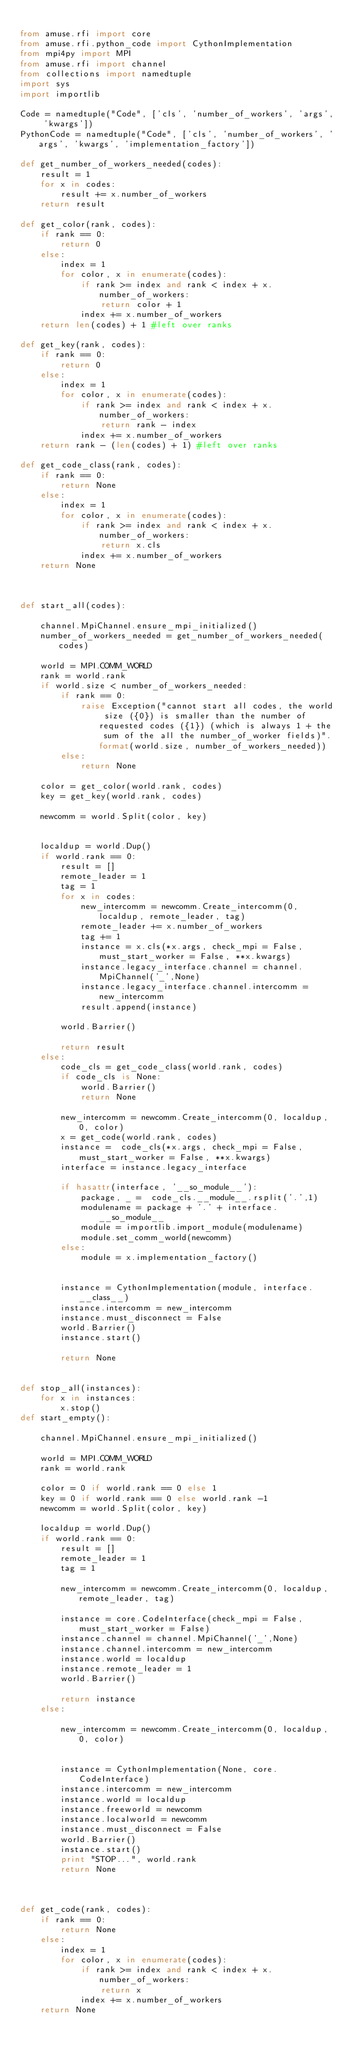Convert code to text. <code><loc_0><loc_0><loc_500><loc_500><_Python_>
from amuse.rfi import core
from amuse.rfi.python_code import CythonImplementation
from mpi4py import MPI
from amuse.rfi import channel
from collections import namedtuple
import sys
import importlib

Code = namedtuple("Code", ['cls', 'number_of_workers', 'args', 'kwargs'])
PythonCode = namedtuple("Code", ['cls', 'number_of_workers', 'args', 'kwargs', 'implementation_factory'])

def get_number_of_workers_needed(codes):
    result = 1
    for x in codes:
        result += x.number_of_workers
    return result

def get_color(rank, codes):
    if rank == 0:
        return 0
    else:
        index = 1
        for color, x in enumerate(codes):
            if rank >= index and rank < index + x.number_of_workers:
                return color + 1
            index += x.number_of_workers
    return len(codes) + 1 #left over ranks
            
def get_key(rank, codes):
    if rank == 0:
        return 0
    else:
        index = 1
        for color, x in enumerate(codes):
            if rank >= index and rank < index + x.number_of_workers:
                return rank - index
            index += x.number_of_workers
    return rank - (len(codes) + 1) #left over ranks

def get_code_class(rank, codes):
    if rank == 0:
        return None
    else:
        index = 1
        for color, x in enumerate(codes):
            if rank >= index and rank < index + x.number_of_workers:
                return x.cls
            index += x.number_of_workers
    return None
            
            

def start_all(codes):
    
    channel.MpiChannel.ensure_mpi_initialized()
    number_of_workers_needed = get_number_of_workers_needed(codes)
    
    world = MPI.COMM_WORLD
    rank = world.rank
    if world.size < number_of_workers_needed:
        if rank == 0:
            raise Exception("cannot start all codes, the world size ({0}) is smaller than the number of requested codes ({1}) (which is always 1 + the sum of the all the number_of_worker fields)".format(world.size, number_of_workers_needed))
        else:
            return None
    
    color = get_color(world.rank, codes)
    key = get_key(world.rank, codes)
    
    newcomm = world.Split(color, key)
    
    
    localdup = world.Dup()
    if world.rank == 0:
        result = []
        remote_leader = 1
        tag = 1
        for x in codes:
            new_intercomm = newcomm.Create_intercomm(0, localdup, remote_leader, tag)
            remote_leader += x.number_of_workers
            tag += 1
            instance = x.cls(*x.args, check_mpi = False, must_start_worker = False, **x.kwargs)
            instance.legacy_interface.channel = channel.MpiChannel('_',None)
            instance.legacy_interface.channel.intercomm = new_intercomm
            result.append(instance)
            
        world.Barrier()
        
        return result    
    else:
        code_cls = get_code_class(world.rank, codes)
        if code_cls is None:
            world.Barrier()
            return None
        
        new_intercomm = newcomm.Create_intercomm(0, localdup, 0, color)
        x = get_code(world.rank, codes)
        instance =  code_cls(*x.args, check_mpi = False, must_start_worker = False, **x.kwargs)
        interface = instance.legacy_interface
       
        if hasattr(interface, '__so_module__'):
            package, _ =  code_cls.__module__.rsplit('.',1)
            modulename = package + '.' + interface.__so_module__
            module = importlib.import_module(modulename)
            module.set_comm_world(newcomm)
        else:
            module = x.implementation_factory()
        
        
        instance = CythonImplementation(module, interface.__class__)
        instance.intercomm = new_intercomm
        instance.must_disconnect = False
        world.Barrier()
        instance.start()
        
        return None
        

def stop_all(instances):
    for x in instances:
        x.stop()
def start_empty():
    
    channel.MpiChannel.ensure_mpi_initialized()
    
    world = MPI.COMM_WORLD
    rank = world.rank
    
    color = 0 if world.rank == 0 else 1
    key = 0 if world.rank == 0 else world.rank -1 
    newcomm = world.Split(color, key)
    
    localdup = world.Dup()
    if world.rank == 0:
        result = []
        remote_leader = 1
        tag = 1
        
        new_intercomm = newcomm.Create_intercomm(0, localdup, remote_leader, tag)
        
        instance = core.CodeInterface(check_mpi = False, must_start_worker = False)
        instance.channel = channel.MpiChannel('_',None)
        instance.channel.intercomm = new_intercomm
        instance.world = localdup  
        instance.remote_leader = 1
        world.Barrier()
        
        return instance    
    else:
        
        new_intercomm = newcomm.Create_intercomm(0, localdup, 0, color)
        
        
        instance = CythonImplementation(None, core.CodeInterface)
        instance.intercomm = new_intercomm
        instance.world = localdup
        instance.freeworld = newcomm
        instance.localworld = newcomm
        instance.must_disconnect = False
        world.Barrier()
        instance.start()
        print "STOP...", world.rank
        return None
        


def get_code(rank, codes):
    if rank == 0:
        return None
    else:
        index = 1
        for color, x in enumerate(codes):
            if rank >= index and rank < index + x.number_of_workers:
                return x
            index += x.number_of_workers
    return None
            
            


</code> 